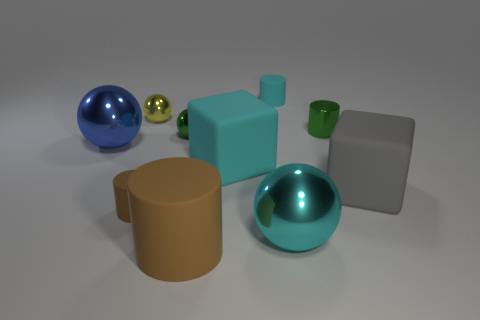Subtract 1 spheres. How many spheres are left? 3 Subtract all cylinders. How many objects are left? 6 Subtract 0 green cubes. How many objects are left? 10 Subtract all cyan matte cylinders. Subtract all big objects. How many objects are left? 4 Add 1 green shiny balls. How many green shiny balls are left? 2 Add 2 yellow metal spheres. How many yellow metal spheres exist? 3 